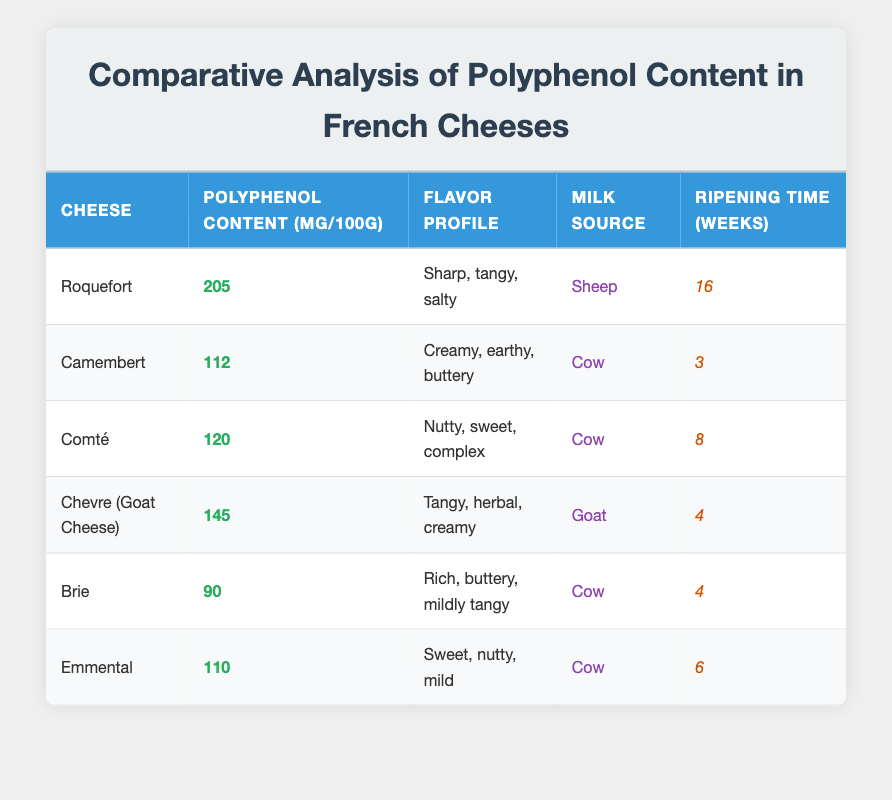What is the cheese with the highest polyphenol content? Roquefort has the highest polyphenol content at 205 mg per 100g, as indicated by the table data.
Answer: Roquefort Is the flavor profile of Chevre described as creamy? Yes, the flavor profile of Chevre is described as tangy, herbal, and creamy according to the table.
Answer: Yes What is the average polyphenol content of cheeses made from cow's milk? The cheeses made from cow's milk are Camembert (112 mg), Comté (120 mg), Brie (90 mg), and Emmental (110 mg). The average is (112 + 120 + 90 + 110) / 4 = 432 / 4 = 108.
Answer: 108 Which cheese has the shortest ripening time and what is that duration? Camembert has the shortest ripening time of 3 weeks, compared to all other cheeses listed.
Answer: 3 weeks Is there a cheese with a polyphenol content less than 100 mg per 100g? No, all cheeses listed have a polyphenol content greater than 90 mg, with Brie being the lowest at 90 mg per 100g.
Answer: No What is the difference in polyphenol content between Roquefort and Brie? The polyphenol content of Roquefort is 205 mg per 100g and Brie is 90 mg per 100g. The difference is 205 - 90 = 115 mg.
Answer: 115 mg Which cheese has a flavor profile described as sweet and nutty? Comté has a flavor profile described as nutty, sweet, and complex, as per the table.
Answer: Comté How many weeks does it take for Chevre to ripen? The table indicates that Chevre takes 4 weeks to ripen.
Answer: 4 weeks What source of milk is used for making Roquefort cheese? The table states that Roquefort is made from sheep's milk.
Answer: Sheep 